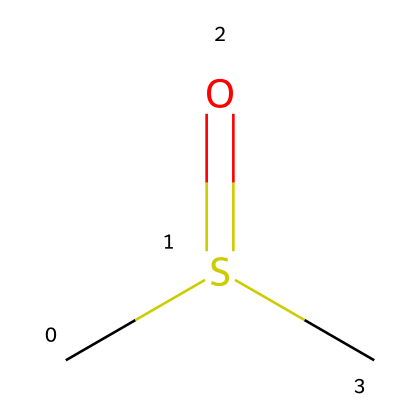What is the molecular formula of DMSO? The molecular formula is derived from the representation: it shows two carbon atoms (C), one sulfur atom (S), and one oxygen atom (O). Thus, the molecular formula is C2H6OS.
Answer: C2H6OS How many oxygen atoms are present in DMSO? By analyzing the chemical structure, only one oxygen atom (O) is present in the composition of DMSO.
Answer: 1 What type of bonding exists between sulfur and oxygen in DMSO? Observing the structure, the sulfur atom has a double bond to the oxygen atom, which is characteristic of a sulfoxide.
Answer: double bond How many hydrogen atoms are attached to each carbon in DMSO? In the chemical structure, each carbon atom is bonded to three hydrogen atoms, indicating they are both fully saturated with hydrogens.
Answer: 3 What functional group is present in DMSO? The presence of the sulfur atom bonded to an oxygen atom (in a sulfonyl) indicates the presence of a sulfoxide functional group.
Answer: sulfoxide What is the hybridization of the sulfur atom in DMSO? The sulfur atom in DMSO forms four bonds (one double bond with oxygen and two single bonds with carbons), indicating sp3 hybridization due to the tetrahedral arrangement of its electrons.
Answer: sp3 What role does DMSO play in science fiction stories? DMSO is often depicted as a powerful solvent and delivery agent in science fiction, sometimes used to enhance the efficacy of drugs or to facilitate chemical reactions due to its unique properties.
Answer: solvent 